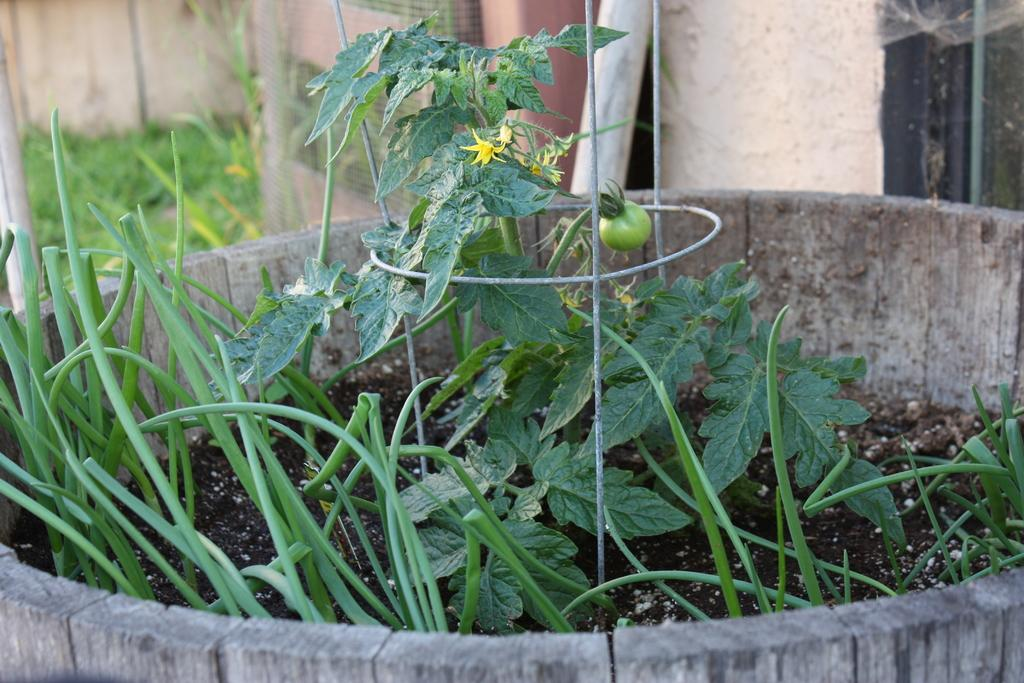What type of container is holding the plants in the image? The plants are in a wooden pot in the image. What can be seen in the background of the image? There is a wall and other objects visible in the background of the image. What type of vegetation is present in the image? Grass is present in the image. What type of prose can be heard being read aloud in the image? There is no indication of any prose being read aloud in the image. How many geese are visible in the image? There are no geese present in the image. 